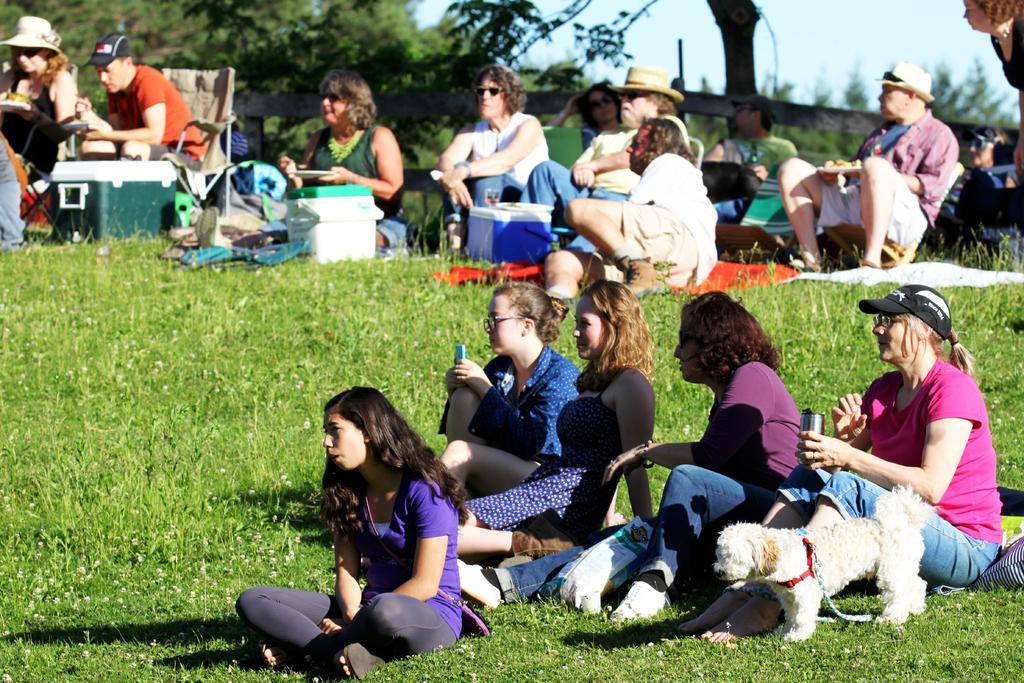In one or two sentences, can you explain what this image depicts? In this picture there are few women sitting on a greenery ground and there is a dog standing beside them and there are some people sitting beside them where few among them are holding eatables in their hands and there are few trees and some other objects in the background. 